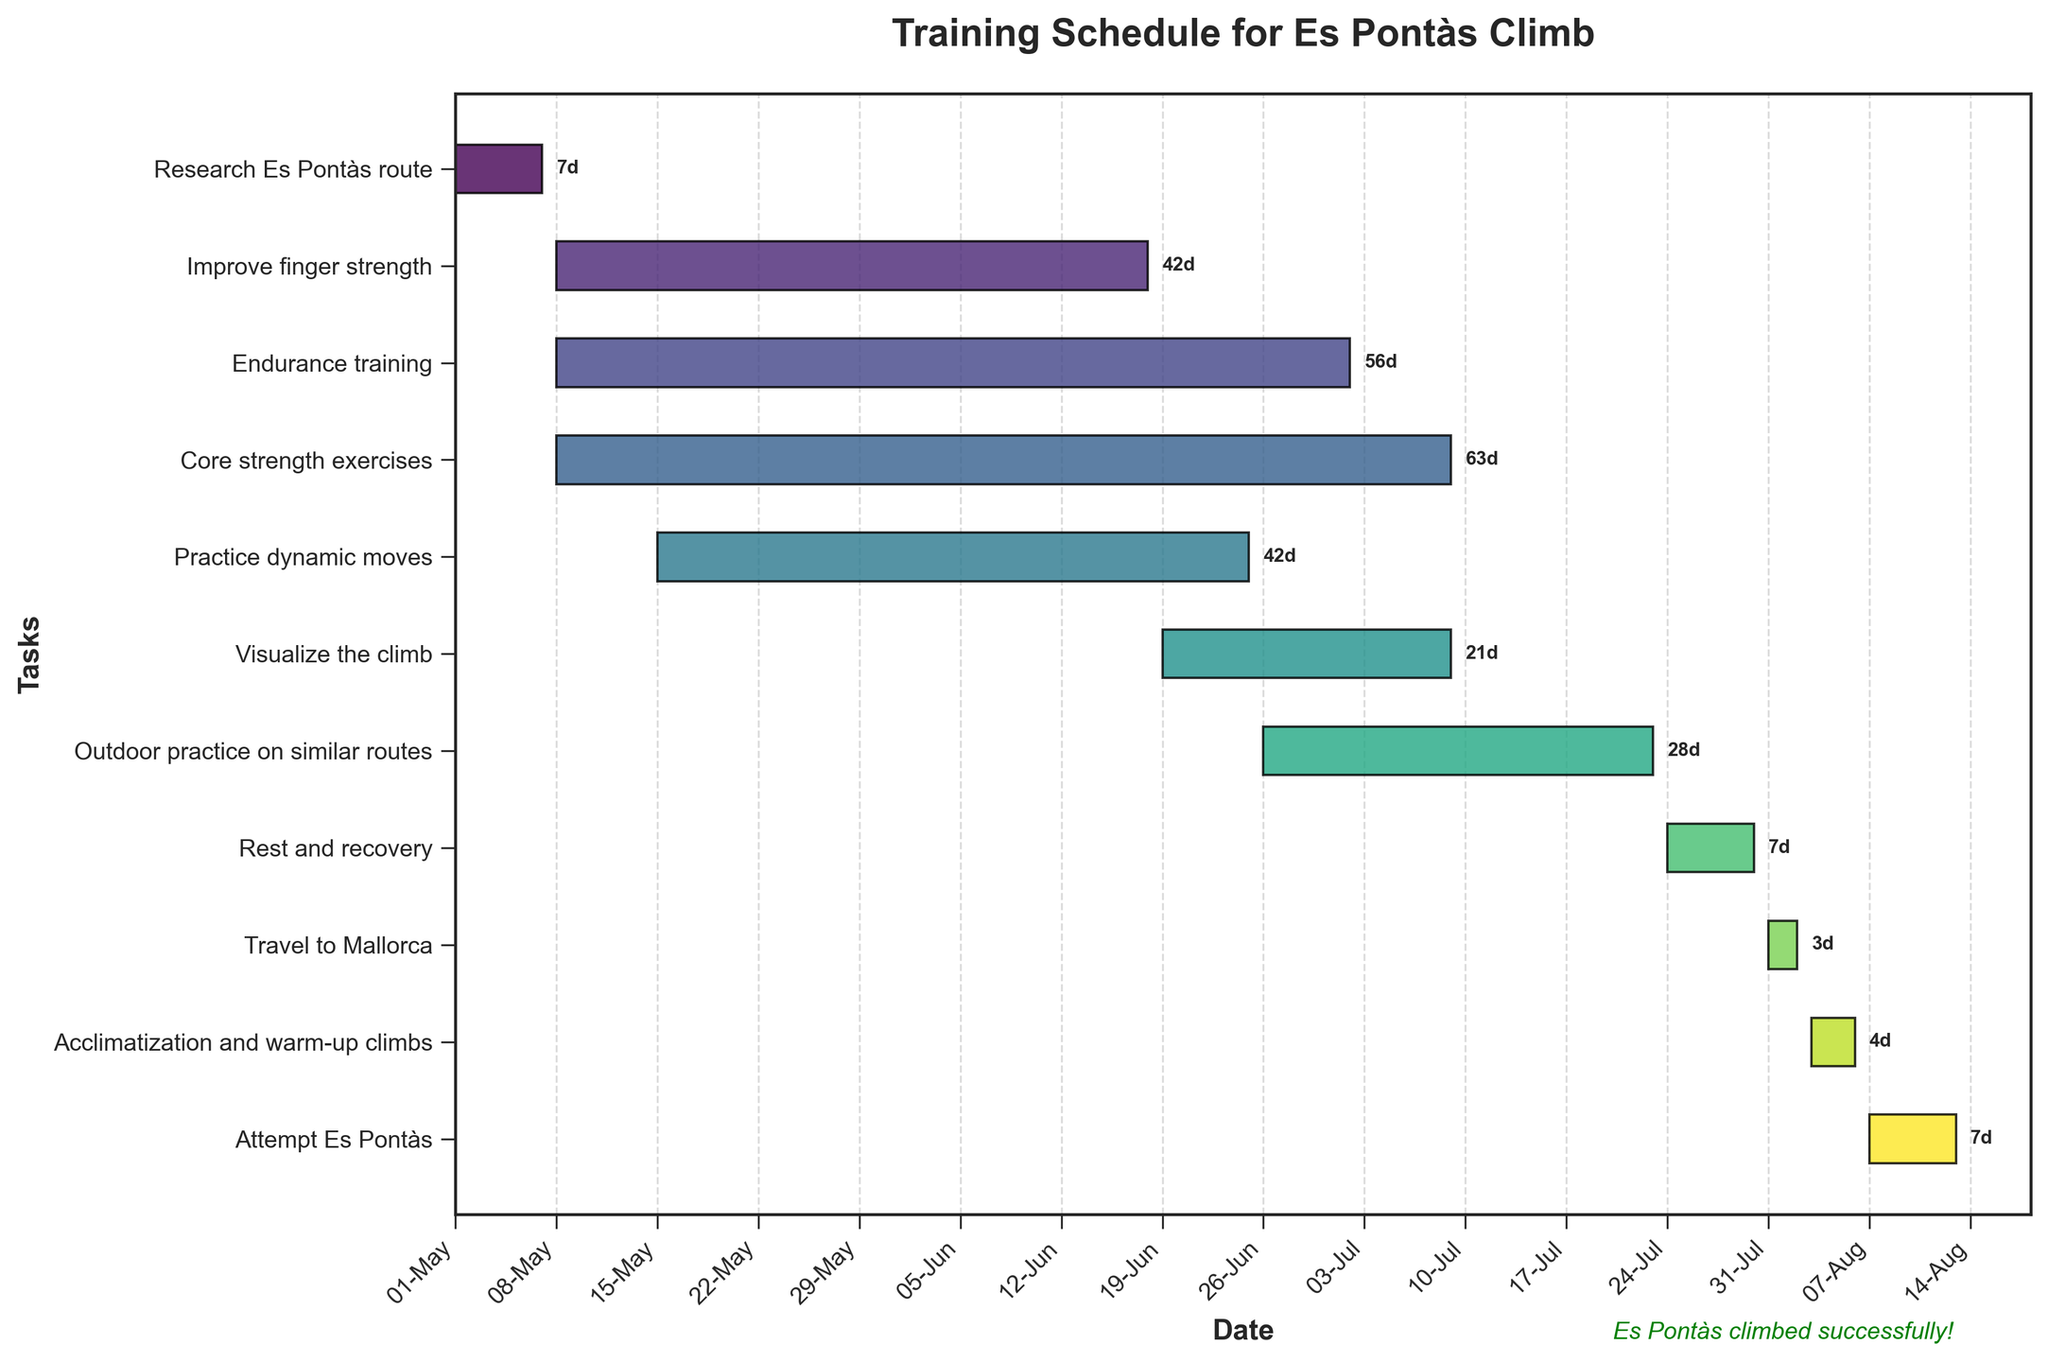What is the duration of the "Research Es Pontàs route" task? Look at the bar for "Research Es Pontàs route" and note the number marking its length, which is 7 days.
Answer: 7 days Which task has the longest duration? By comparing the lengths of the bars, "Core strength exercises" has the longest duration of 63 days.
Answer: Core strength exercises How many tasks start in May? From the start dates along the x-axis, identify all tasks that start in May: "Research Es Pontàs route," "Improve finger strength," "Endurance training," "Practice dynamic moves," and "Core strength exercises." This totals 5 tasks.
Answer: 5 tasks What is the overall duration from the start of "Research Es Pontàs route" to the end of "Attempt Es Pontàs"? "Research Es Pontàs route" starts on May 1st, and "Attempt Es Pontàs" ends on August 13th. Count the days from May 1st to August 13th: 104 days.
Answer: 104 days Which task directly follows "Outdoor practice on similar routes"? Looking at the timeline, "Rest and recovery" starts right after "Outdoor practice on similar routes" ends.
Answer: Rest and recovery How long after starting the "Visualize the climb" task does "Attempt Es Pontàs" begin? "Visualize the climb" starts on June 19th, and "Attempt Es Pontàs" starts on August 7th. The number of days between these dates is 49 days.
Answer: 49 days Which task has the earliest start date? By checking the start dates of all tasks, "Research Es Pontàs route" starts the earliest on May 1st.
Answer: Research Es Pontàs route What is the total combined duration of "Improve finger strength" and "Practice dynamic moves"? "Improve finger strength" lasts 42 days, and "Practice dynamic moves" also lasts 42 days. Adding them together: 42 days + 42 days = 84 days.
Answer: 84 days When does the "Travel to Mallorca" task take place? Refer to the timeline: "Travel to Mallorca" is scheduled from July 31st to August 2nd.
Answer: July 31st to August 2nd Are there any tasks that start and end in July? If yes, which ones? Examining the July timeline, no tasks start and end entirely within July.
Answer: No 